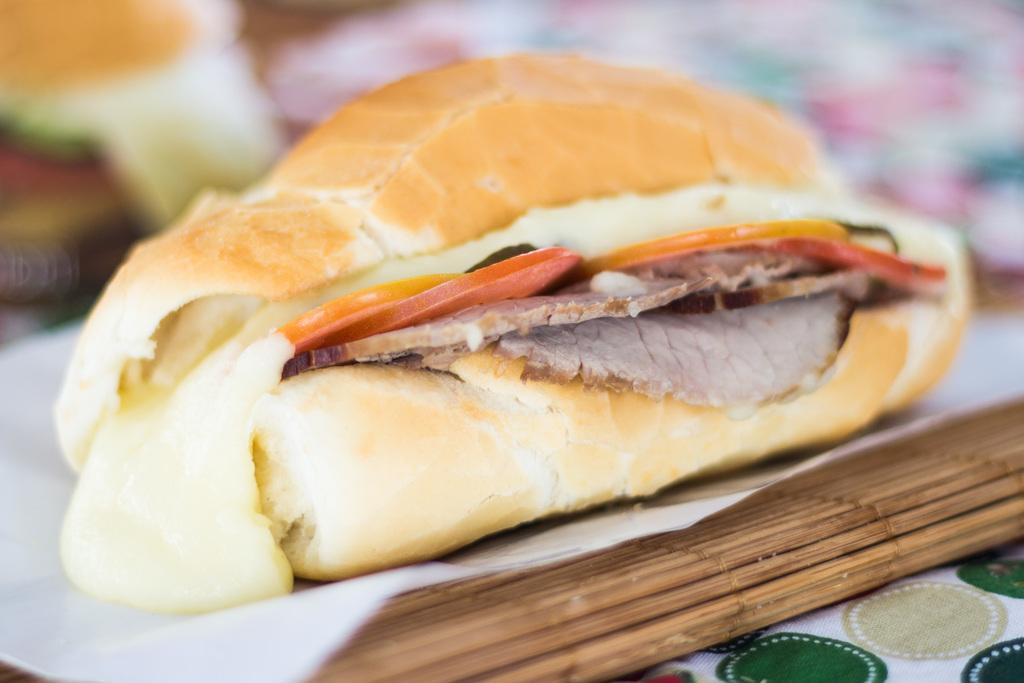What is the main subject of the image? There is a food item in the image. How is the food item presented in the image? The food item is on tissue paper. What type of silk material is used as a tablecloth in the image? There is no silk material or tablecloth present in the image. 